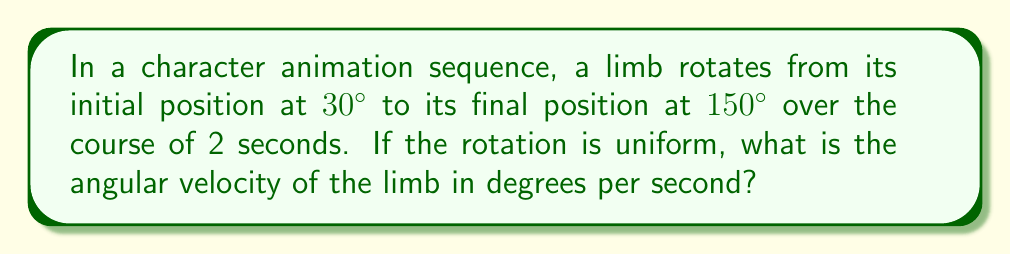Can you solve this math problem? To solve this problem, we need to follow these steps:

1. Calculate the total angle of rotation:
   $$\text{Total rotation} = \text{Final position} - \text{Initial position}$$
   $$\text{Total rotation} = 150° - 30° = 120°$$

2. Determine the time taken for the rotation:
   The rotation occurs over 2 seconds.

3. Calculate the angular velocity using the formula:
   $$\text{Angular velocity} = \frac{\text{Total rotation}}{\text{Time taken}}$$

4. Substitute the values:
   $$\text{Angular velocity} = \frac{120°}{2\text{ seconds}}$$

5. Perform the division:
   $$\text{Angular velocity} = 60°/\text{second}$$

Therefore, the limb rotates at an angular velocity of 60 degrees per second during the animation.
Answer: $60°/\text{second}$ 